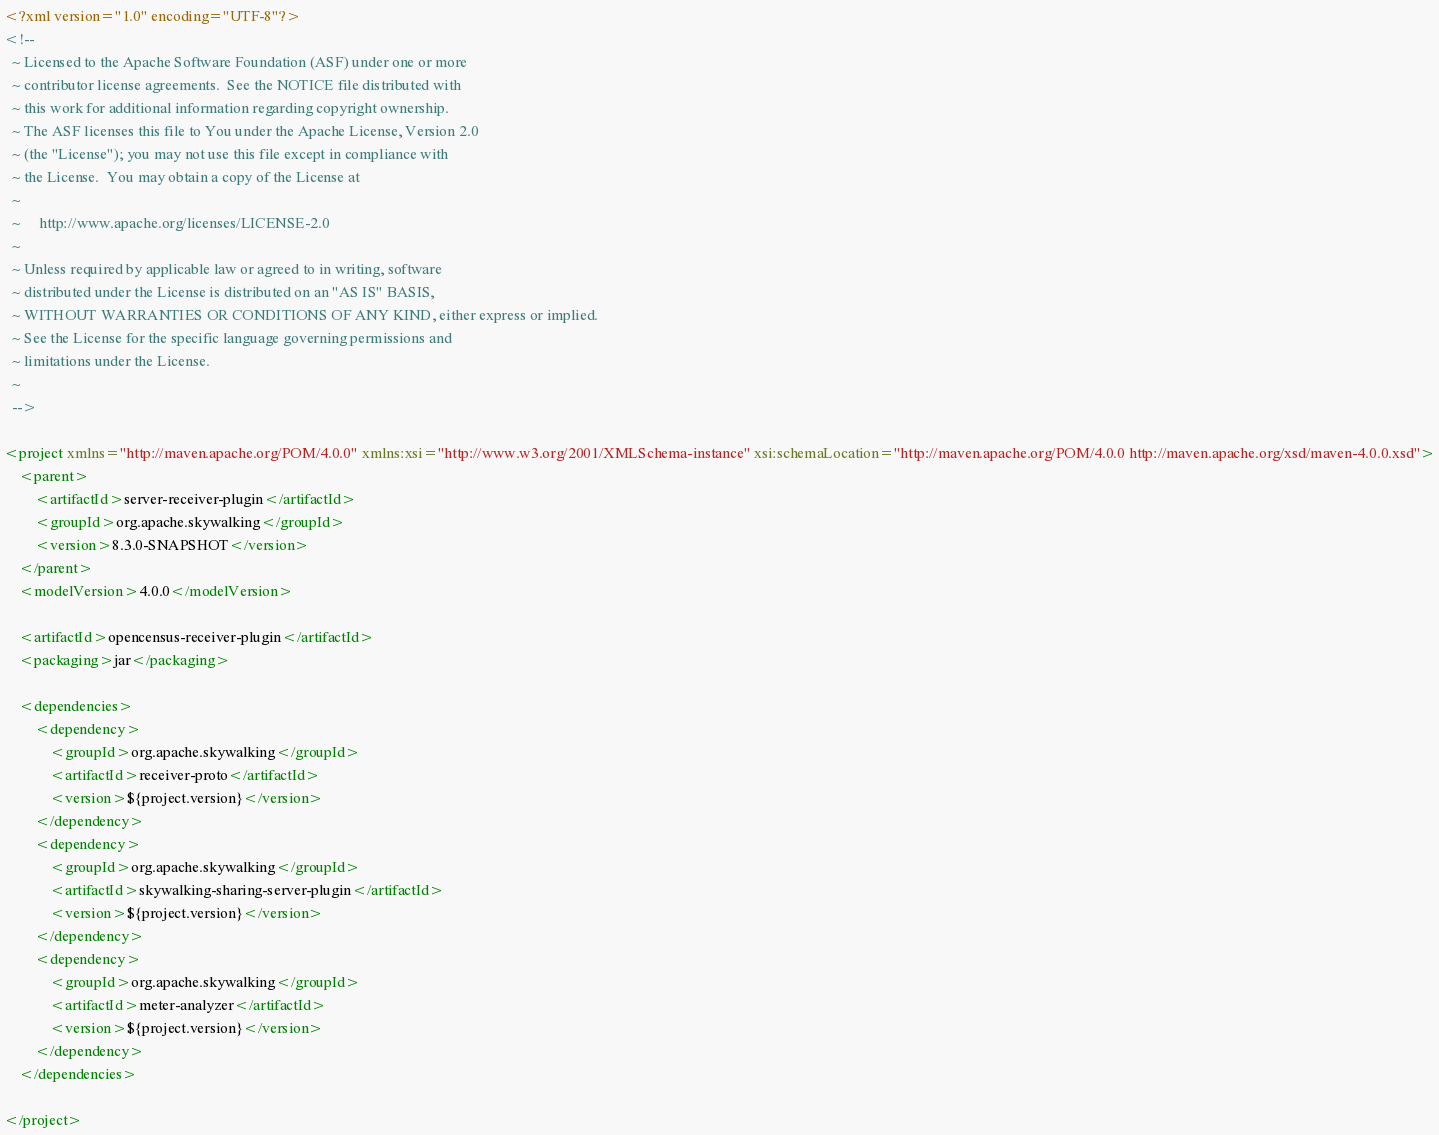<code> <loc_0><loc_0><loc_500><loc_500><_XML_><?xml version="1.0" encoding="UTF-8"?>
<!--
  ~ Licensed to the Apache Software Foundation (ASF) under one or more
  ~ contributor license agreements.  See the NOTICE file distributed with
  ~ this work for additional information regarding copyright ownership.
  ~ The ASF licenses this file to You under the Apache License, Version 2.0
  ~ (the "License"); you may not use this file except in compliance with
  ~ the License.  You may obtain a copy of the License at
  ~
  ~     http://www.apache.org/licenses/LICENSE-2.0
  ~
  ~ Unless required by applicable law or agreed to in writing, software
  ~ distributed under the License is distributed on an "AS IS" BASIS,
  ~ WITHOUT WARRANTIES OR CONDITIONS OF ANY KIND, either express or implied.
  ~ See the License for the specific language governing permissions and
  ~ limitations under the License.
  ~
  -->

<project xmlns="http://maven.apache.org/POM/4.0.0" xmlns:xsi="http://www.w3.org/2001/XMLSchema-instance" xsi:schemaLocation="http://maven.apache.org/POM/4.0.0 http://maven.apache.org/xsd/maven-4.0.0.xsd">
    <parent>
        <artifactId>server-receiver-plugin</artifactId>
        <groupId>org.apache.skywalking</groupId>
        <version>8.3.0-SNAPSHOT</version>
    </parent>
    <modelVersion>4.0.0</modelVersion>

    <artifactId>opencensus-receiver-plugin</artifactId>
    <packaging>jar</packaging>

    <dependencies>
        <dependency>
            <groupId>org.apache.skywalking</groupId>
            <artifactId>receiver-proto</artifactId>
            <version>${project.version}</version>
        </dependency>
        <dependency>
            <groupId>org.apache.skywalking</groupId>
            <artifactId>skywalking-sharing-server-plugin</artifactId>
            <version>${project.version}</version>
        </dependency>
        <dependency>
            <groupId>org.apache.skywalking</groupId>
            <artifactId>meter-analyzer</artifactId>
            <version>${project.version}</version>
        </dependency>
    </dependencies>

</project></code> 